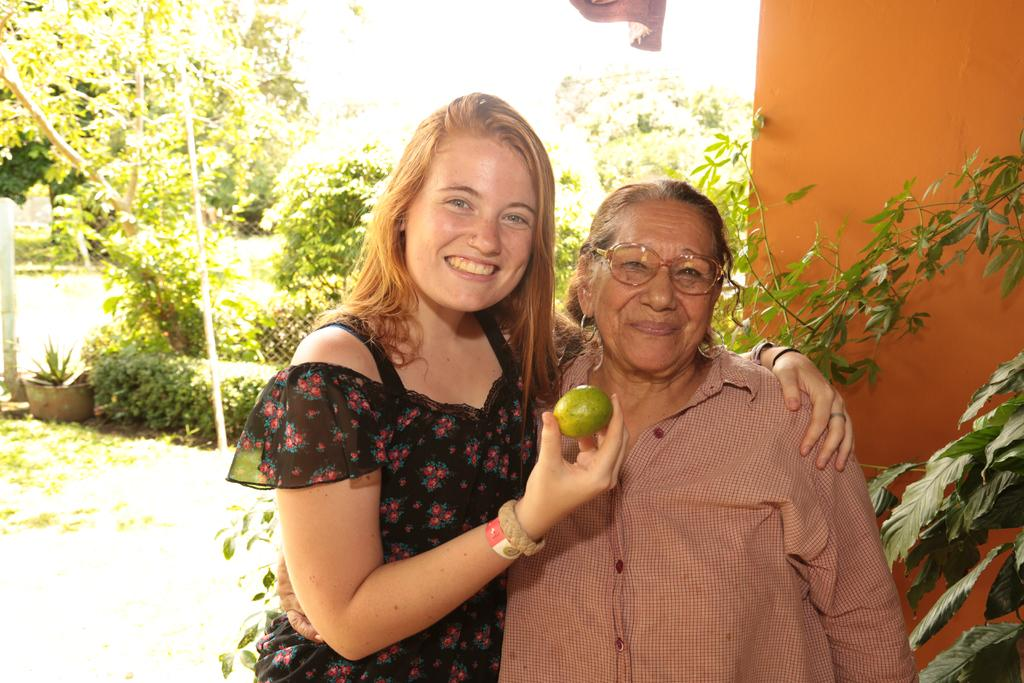How many people are present in the image? There are two people in the image. What is the facial expression of the people in the image? Both people are smiling. What is one of the people holding in her hand? One of the people is holding a fruit in her hand. What can be seen in the background of the image? There is a wall, trees, and plants in the background of the image. What type of tax is being discussed by the people in the image? There is no indication in the image that the people are discussing any type of tax. Can you tell me how the coast is affecting the experience of the people in the image? There is no coast visible in the image, and therefore it cannot be determined how it might be affecting the experience of the people. 